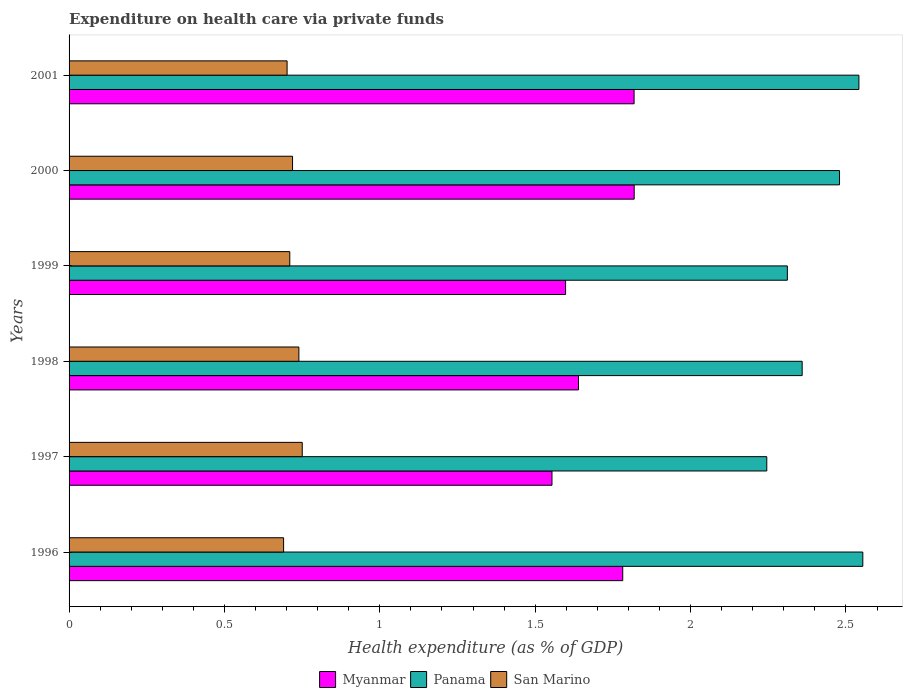How many different coloured bars are there?
Provide a succinct answer. 3. Are the number of bars per tick equal to the number of legend labels?
Offer a terse response. Yes. Are the number of bars on each tick of the Y-axis equal?
Keep it short and to the point. Yes. How many bars are there on the 6th tick from the top?
Your response must be concise. 3. How many bars are there on the 1st tick from the bottom?
Keep it short and to the point. 3. In how many cases, is the number of bars for a given year not equal to the number of legend labels?
Give a very brief answer. 0. What is the expenditure made on health care in Panama in 1996?
Give a very brief answer. 2.55. Across all years, what is the maximum expenditure made on health care in San Marino?
Your answer should be compact. 0.75. Across all years, what is the minimum expenditure made on health care in Myanmar?
Give a very brief answer. 1.55. What is the total expenditure made on health care in San Marino in the graph?
Offer a terse response. 4.31. What is the difference between the expenditure made on health care in Myanmar in 1997 and that in 2000?
Provide a short and direct response. -0.26. What is the difference between the expenditure made on health care in Panama in 2000 and the expenditure made on health care in Myanmar in 1998?
Offer a very short reply. 0.84. What is the average expenditure made on health care in San Marino per year?
Ensure brevity in your answer.  0.72. In the year 1996, what is the difference between the expenditure made on health care in Myanmar and expenditure made on health care in Panama?
Ensure brevity in your answer.  -0.77. What is the ratio of the expenditure made on health care in Myanmar in 1997 to that in 2001?
Your answer should be compact. 0.85. Is the difference between the expenditure made on health care in Myanmar in 1996 and 1999 greater than the difference between the expenditure made on health care in Panama in 1996 and 1999?
Your answer should be very brief. No. What is the difference between the highest and the second highest expenditure made on health care in Myanmar?
Provide a succinct answer. 0. What is the difference between the highest and the lowest expenditure made on health care in San Marino?
Your answer should be compact. 0.06. In how many years, is the expenditure made on health care in Myanmar greater than the average expenditure made on health care in Myanmar taken over all years?
Provide a short and direct response. 3. Is the sum of the expenditure made on health care in Panama in 1997 and 1998 greater than the maximum expenditure made on health care in San Marino across all years?
Provide a short and direct response. Yes. What does the 2nd bar from the top in 1999 represents?
Give a very brief answer. Panama. What does the 2nd bar from the bottom in 1999 represents?
Offer a very short reply. Panama. How many years are there in the graph?
Give a very brief answer. 6. Are the values on the major ticks of X-axis written in scientific E-notation?
Your answer should be compact. No. Where does the legend appear in the graph?
Provide a short and direct response. Bottom center. How many legend labels are there?
Your answer should be compact. 3. How are the legend labels stacked?
Your response must be concise. Horizontal. What is the title of the graph?
Your answer should be compact. Expenditure on health care via private funds. What is the label or title of the X-axis?
Offer a terse response. Health expenditure (as % of GDP). What is the Health expenditure (as % of GDP) of Myanmar in 1996?
Provide a short and direct response. 1.78. What is the Health expenditure (as % of GDP) in Panama in 1996?
Your answer should be very brief. 2.55. What is the Health expenditure (as % of GDP) of San Marino in 1996?
Offer a very short reply. 0.69. What is the Health expenditure (as % of GDP) of Myanmar in 1997?
Provide a succinct answer. 1.55. What is the Health expenditure (as % of GDP) in Panama in 1997?
Ensure brevity in your answer.  2.25. What is the Health expenditure (as % of GDP) of San Marino in 1997?
Your answer should be very brief. 0.75. What is the Health expenditure (as % of GDP) in Myanmar in 1998?
Your response must be concise. 1.64. What is the Health expenditure (as % of GDP) in Panama in 1998?
Give a very brief answer. 2.36. What is the Health expenditure (as % of GDP) in San Marino in 1998?
Ensure brevity in your answer.  0.74. What is the Health expenditure (as % of GDP) in Myanmar in 1999?
Your answer should be compact. 1.6. What is the Health expenditure (as % of GDP) of Panama in 1999?
Provide a succinct answer. 2.31. What is the Health expenditure (as % of GDP) in San Marino in 1999?
Your answer should be very brief. 0.71. What is the Health expenditure (as % of GDP) of Myanmar in 2000?
Make the answer very short. 1.82. What is the Health expenditure (as % of GDP) in Panama in 2000?
Ensure brevity in your answer.  2.48. What is the Health expenditure (as % of GDP) in San Marino in 2000?
Offer a terse response. 0.72. What is the Health expenditure (as % of GDP) in Myanmar in 2001?
Ensure brevity in your answer.  1.82. What is the Health expenditure (as % of GDP) in Panama in 2001?
Offer a terse response. 2.54. What is the Health expenditure (as % of GDP) of San Marino in 2001?
Provide a short and direct response. 0.7. Across all years, what is the maximum Health expenditure (as % of GDP) of Myanmar?
Your answer should be compact. 1.82. Across all years, what is the maximum Health expenditure (as % of GDP) of Panama?
Your answer should be compact. 2.55. Across all years, what is the maximum Health expenditure (as % of GDP) of San Marino?
Your answer should be very brief. 0.75. Across all years, what is the minimum Health expenditure (as % of GDP) of Myanmar?
Ensure brevity in your answer.  1.55. Across all years, what is the minimum Health expenditure (as % of GDP) in Panama?
Offer a very short reply. 2.25. Across all years, what is the minimum Health expenditure (as % of GDP) in San Marino?
Keep it short and to the point. 0.69. What is the total Health expenditure (as % of GDP) of Myanmar in the graph?
Provide a succinct answer. 10.21. What is the total Health expenditure (as % of GDP) of Panama in the graph?
Offer a very short reply. 14.49. What is the total Health expenditure (as % of GDP) in San Marino in the graph?
Give a very brief answer. 4.31. What is the difference between the Health expenditure (as % of GDP) in Myanmar in 1996 and that in 1997?
Your response must be concise. 0.23. What is the difference between the Health expenditure (as % of GDP) of Panama in 1996 and that in 1997?
Your answer should be compact. 0.31. What is the difference between the Health expenditure (as % of GDP) of San Marino in 1996 and that in 1997?
Provide a succinct answer. -0.06. What is the difference between the Health expenditure (as % of GDP) of Myanmar in 1996 and that in 1998?
Ensure brevity in your answer.  0.14. What is the difference between the Health expenditure (as % of GDP) in Panama in 1996 and that in 1998?
Your answer should be very brief. 0.2. What is the difference between the Health expenditure (as % of GDP) in San Marino in 1996 and that in 1998?
Make the answer very short. -0.05. What is the difference between the Health expenditure (as % of GDP) in Myanmar in 1996 and that in 1999?
Your response must be concise. 0.18. What is the difference between the Health expenditure (as % of GDP) of Panama in 1996 and that in 1999?
Your response must be concise. 0.24. What is the difference between the Health expenditure (as % of GDP) of San Marino in 1996 and that in 1999?
Your answer should be compact. -0.02. What is the difference between the Health expenditure (as % of GDP) in Myanmar in 1996 and that in 2000?
Keep it short and to the point. -0.04. What is the difference between the Health expenditure (as % of GDP) of Panama in 1996 and that in 2000?
Make the answer very short. 0.07. What is the difference between the Health expenditure (as % of GDP) in San Marino in 1996 and that in 2000?
Your answer should be compact. -0.03. What is the difference between the Health expenditure (as % of GDP) of Myanmar in 1996 and that in 2001?
Your response must be concise. -0.04. What is the difference between the Health expenditure (as % of GDP) in Panama in 1996 and that in 2001?
Your answer should be compact. 0.01. What is the difference between the Health expenditure (as % of GDP) of San Marino in 1996 and that in 2001?
Your answer should be very brief. -0.01. What is the difference between the Health expenditure (as % of GDP) of Myanmar in 1997 and that in 1998?
Provide a short and direct response. -0.09. What is the difference between the Health expenditure (as % of GDP) in Panama in 1997 and that in 1998?
Keep it short and to the point. -0.11. What is the difference between the Health expenditure (as % of GDP) in San Marino in 1997 and that in 1998?
Offer a very short reply. 0.01. What is the difference between the Health expenditure (as % of GDP) in Myanmar in 1997 and that in 1999?
Offer a terse response. -0.04. What is the difference between the Health expenditure (as % of GDP) of Panama in 1997 and that in 1999?
Keep it short and to the point. -0.07. What is the difference between the Health expenditure (as % of GDP) of San Marino in 1997 and that in 1999?
Make the answer very short. 0.04. What is the difference between the Health expenditure (as % of GDP) in Myanmar in 1997 and that in 2000?
Keep it short and to the point. -0.26. What is the difference between the Health expenditure (as % of GDP) of Panama in 1997 and that in 2000?
Your response must be concise. -0.23. What is the difference between the Health expenditure (as % of GDP) in San Marino in 1997 and that in 2000?
Ensure brevity in your answer.  0.03. What is the difference between the Health expenditure (as % of GDP) of Myanmar in 1997 and that in 2001?
Provide a short and direct response. -0.26. What is the difference between the Health expenditure (as % of GDP) in Panama in 1997 and that in 2001?
Offer a terse response. -0.3. What is the difference between the Health expenditure (as % of GDP) of San Marino in 1997 and that in 2001?
Keep it short and to the point. 0.05. What is the difference between the Health expenditure (as % of GDP) of Myanmar in 1998 and that in 1999?
Provide a succinct answer. 0.04. What is the difference between the Health expenditure (as % of GDP) of Panama in 1998 and that in 1999?
Give a very brief answer. 0.05. What is the difference between the Health expenditure (as % of GDP) of San Marino in 1998 and that in 1999?
Your answer should be very brief. 0.03. What is the difference between the Health expenditure (as % of GDP) in Myanmar in 1998 and that in 2000?
Your response must be concise. -0.18. What is the difference between the Health expenditure (as % of GDP) of Panama in 1998 and that in 2000?
Keep it short and to the point. -0.12. What is the difference between the Health expenditure (as % of GDP) of San Marino in 1998 and that in 2000?
Your answer should be very brief. 0.02. What is the difference between the Health expenditure (as % of GDP) in Myanmar in 1998 and that in 2001?
Offer a very short reply. -0.18. What is the difference between the Health expenditure (as % of GDP) in Panama in 1998 and that in 2001?
Your answer should be very brief. -0.18. What is the difference between the Health expenditure (as % of GDP) in San Marino in 1998 and that in 2001?
Make the answer very short. 0.04. What is the difference between the Health expenditure (as % of GDP) in Myanmar in 1999 and that in 2000?
Provide a short and direct response. -0.22. What is the difference between the Health expenditure (as % of GDP) in Panama in 1999 and that in 2000?
Provide a short and direct response. -0.17. What is the difference between the Health expenditure (as % of GDP) of San Marino in 1999 and that in 2000?
Offer a terse response. -0.01. What is the difference between the Health expenditure (as % of GDP) of Myanmar in 1999 and that in 2001?
Provide a succinct answer. -0.22. What is the difference between the Health expenditure (as % of GDP) in Panama in 1999 and that in 2001?
Your response must be concise. -0.23. What is the difference between the Health expenditure (as % of GDP) of San Marino in 1999 and that in 2001?
Your response must be concise. 0.01. What is the difference between the Health expenditure (as % of GDP) of Myanmar in 2000 and that in 2001?
Provide a succinct answer. 0. What is the difference between the Health expenditure (as % of GDP) of Panama in 2000 and that in 2001?
Offer a very short reply. -0.06. What is the difference between the Health expenditure (as % of GDP) in San Marino in 2000 and that in 2001?
Your response must be concise. 0.02. What is the difference between the Health expenditure (as % of GDP) of Myanmar in 1996 and the Health expenditure (as % of GDP) of Panama in 1997?
Your answer should be very brief. -0.46. What is the difference between the Health expenditure (as % of GDP) of Myanmar in 1996 and the Health expenditure (as % of GDP) of San Marino in 1997?
Offer a terse response. 1.03. What is the difference between the Health expenditure (as % of GDP) in Panama in 1996 and the Health expenditure (as % of GDP) in San Marino in 1997?
Make the answer very short. 1.8. What is the difference between the Health expenditure (as % of GDP) in Myanmar in 1996 and the Health expenditure (as % of GDP) in Panama in 1998?
Offer a terse response. -0.58. What is the difference between the Health expenditure (as % of GDP) in Myanmar in 1996 and the Health expenditure (as % of GDP) in San Marino in 1998?
Give a very brief answer. 1.04. What is the difference between the Health expenditure (as % of GDP) of Panama in 1996 and the Health expenditure (as % of GDP) of San Marino in 1998?
Keep it short and to the point. 1.81. What is the difference between the Health expenditure (as % of GDP) of Myanmar in 1996 and the Health expenditure (as % of GDP) of Panama in 1999?
Give a very brief answer. -0.53. What is the difference between the Health expenditure (as % of GDP) of Myanmar in 1996 and the Health expenditure (as % of GDP) of San Marino in 1999?
Keep it short and to the point. 1.07. What is the difference between the Health expenditure (as % of GDP) in Panama in 1996 and the Health expenditure (as % of GDP) in San Marino in 1999?
Offer a very short reply. 1.84. What is the difference between the Health expenditure (as % of GDP) in Myanmar in 1996 and the Health expenditure (as % of GDP) in Panama in 2000?
Keep it short and to the point. -0.7. What is the difference between the Health expenditure (as % of GDP) of Panama in 1996 and the Health expenditure (as % of GDP) of San Marino in 2000?
Offer a terse response. 1.83. What is the difference between the Health expenditure (as % of GDP) in Myanmar in 1996 and the Health expenditure (as % of GDP) in Panama in 2001?
Make the answer very short. -0.76. What is the difference between the Health expenditure (as % of GDP) in Panama in 1996 and the Health expenditure (as % of GDP) in San Marino in 2001?
Ensure brevity in your answer.  1.85. What is the difference between the Health expenditure (as % of GDP) in Myanmar in 1997 and the Health expenditure (as % of GDP) in Panama in 1998?
Offer a terse response. -0.81. What is the difference between the Health expenditure (as % of GDP) in Myanmar in 1997 and the Health expenditure (as % of GDP) in San Marino in 1998?
Provide a short and direct response. 0.81. What is the difference between the Health expenditure (as % of GDP) of Panama in 1997 and the Health expenditure (as % of GDP) of San Marino in 1998?
Provide a succinct answer. 1.51. What is the difference between the Health expenditure (as % of GDP) of Myanmar in 1997 and the Health expenditure (as % of GDP) of Panama in 1999?
Provide a succinct answer. -0.76. What is the difference between the Health expenditure (as % of GDP) in Myanmar in 1997 and the Health expenditure (as % of GDP) in San Marino in 1999?
Ensure brevity in your answer.  0.84. What is the difference between the Health expenditure (as % of GDP) in Panama in 1997 and the Health expenditure (as % of GDP) in San Marino in 1999?
Offer a very short reply. 1.53. What is the difference between the Health expenditure (as % of GDP) in Myanmar in 1997 and the Health expenditure (as % of GDP) in Panama in 2000?
Offer a terse response. -0.93. What is the difference between the Health expenditure (as % of GDP) of Myanmar in 1997 and the Health expenditure (as % of GDP) of San Marino in 2000?
Ensure brevity in your answer.  0.83. What is the difference between the Health expenditure (as % of GDP) in Panama in 1997 and the Health expenditure (as % of GDP) in San Marino in 2000?
Provide a succinct answer. 1.53. What is the difference between the Health expenditure (as % of GDP) of Myanmar in 1997 and the Health expenditure (as % of GDP) of Panama in 2001?
Your response must be concise. -0.99. What is the difference between the Health expenditure (as % of GDP) of Myanmar in 1997 and the Health expenditure (as % of GDP) of San Marino in 2001?
Offer a terse response. 0.85. What is the difference between the Health expenditure (as % of GDP) in Panama in 1997 and the Health expenditure (as % of GDP) in San Marino in 2001?
Ensure brevity in your answer.  1.54. What is the difference between the Health expenditure (as % of GDP) in Myanmar in 1998 and the Health expenditure (as % of GDP) in Panama in 1999?
Your answer should be compact. -0.67. What is the difference between the Health expenditure (as % of GDP) in Myanmar in 1998 and the Health expenditure (as % of GDP) in San Marino in 1999?
Your answer should be compact. 0.93. What is the difference between the Health expenditure (as % of GDP) in Panama in 1998 and the Health expenditure (as % of GDP) in San Marino in 1999?
Offer a very short reply. 1.65. What is the difference between the Health expenditure (as % of GDP) in Myanmar in 1998 and the Health expenditure (as % of GDP) in Panama in 2000?
Make the answer very short. -0.84. What is the difference between the Health expenditure (as % of GDP) in Myanmar in 1998 and the Health expenditure (as % of GDP) in San Marino in 2000?
Provide a succinct answer. 0.92. What is the difference between the Health expenditure (as % of GDP) in Panama in 1998 and the Health expenditure (as % of GDP) in San Marino in 2000?
Provide a short and direct response. 1.64. What is the difference between the Health expenditure (as % of GDP) of Myanmar in 1998 and the Health expenditure (as % of GDP) of Panama in 2001?
Keep it short and to the point. -0.9. What is the difference between the Health expenditure (as % of GDP) in Myanmar in 1998 and the Health expenditure (as % of GDP) in San Marino in 2001?
Provide a short and direct response. 0.94. What is the difference between the Health expenditure (as % of GDP) of Panama in 1998 and the Health expenditure (as % of GDP) of San Marino in 2001?
Provide a short and direct response. 1.66. What is the difference between the Health expenditure (as % of GDP) in Myanmar in 1999 and the Health expenditure (as % of GDP) in Panama in 2000?
Offer a very short reply. -0.88. What is the difference between the Health expenditure (as % of GDP) of Myanmar in 1999 and the Health expenditure (as % of GDP) of San Marino in 2000?
Your answer should be compact. 0.88. What is the difference between the Health expenditure (as % of GDP) in Panama in 1999 and the Health expenditure (as % of GDP) in San Marino in 2000?
Keep it short and to the point. 1.59. What is the difference between the Health expenditure (as % of GDP) of Myanmar in 1999 and the Health expenditure (as % of GDP) of Panama in 2001?
Ensure brevity in your answer.  -0.94. What is the difference between the Health expenditure (as % of GDP) in Myanmar in 1999 and the Health expenditure (as % of GDP) in San Marino in 2001?
Give a very brief answer. 0.9. What is the difference between the Health expenditure (as % of GDP) of Panama in 1999 and the Health expenditure (as % of GDP) of San Marino in 2001?
Keep it short and to the point. 1.61. What is the difference between the Health expenditure (as % of GDP) in Myanmar in 2000 and the Health expenditure (as % of GDP) in Panama in 2001?
Your answer should be very brief. -0.72. What is the difference between the Health expenditure (as % of GDP) of Myanmar in 2000 and the Health expenditure (as % of GDP) of San Marino in 2001?
Keep it short and to the point. 1.12. What is the difference between the Health expenditure (as % of GDP) of Panama in 2000 and the Health expenditure (as % of GDP) of San Marino in 2001?
Offer a terse response. 1.78. What is the average Health expenditure (as % of GDP) in Myanmar per year?
Provide a succinct answer. 1.7. What is the average Health expenditure (as % of GDP) of Panama per year?
Your answer should be compact. 2.42. What is the average Health expenditure (as % of GDP) in San Marino per year?
Ensure brevity in your answer.  0.72. In the year 1996, what is the difference between the Health expenditure (as % of GDP) in Myanmar and Health expenditure (as % of GDP) in Panama?
Ensure brevity in your answer.  -0.77. In the year 1996, what is the difference between the Health expenditure (as % of GDP) of Myanmar and Health expenditure (as % of GDP) of San Marino?
Keep it short and to the point. 1.09. In the year 1996, what is the difference between the Health expenditure (as % of GDP) of Panama and Health expenditure (as % of GDP) of San Marino?
Provide a short and direct response. 1.86. In the year 1997, what is the difference between the Health expenditure (as % of GDP) in Myanmar and Health expenditure (as % of GDP) in Panama?
Ensure brevity in your answer.  -0.69. In the year 1997, what is the difference between the Health expenditure (as % of GDP) of Myanmar and Health expenditure (as % of GDP) of San Marino?
Offer a very short reply. 0.8. In the year 1997, what is the difference between the Health expenditure (as % of GDP) in Panama and Health expenditure (as % of GDP) in San Marino?
Offer a terse response. 1.49. In the year 1998, what is the difference between the Health expenditure (as % of GDP) in Myanmar and Health expenditure (as % of GDP) in Panama?
Offer a terse response. -0.72. In the year 1998, what is the difference between the Health expenditure (as % of GDP) of Myanmar and Health expenditure (as % of GDP) of San Marino?
Your response must be concise. 0.9. In the year 1998, what is the difference between the Health expenditure (as % of GDP) in Panama and Health expenditure (as % of GDP) in San Marino?
Your answer should be compact. 1.62. In the year 1999, what is the difference between the Health expenditure (as % of GDP) of Myanmar and Health expenditure (as % of GDP) of Panama?
Your answer should be compact. -0.71. In the year 1999, what is the difference between the Health expenditure (as % of GDP) in Myanmar and Health expenditure (as % of GDP) in San Marino?
Provide a short and direct response. 0.89. In the year 1999, what is the difference between the Health expenditure (as % of GDP) in Panama and Health expenditure (as % of GDP) in San Marino?
Offer a terse response. 1.6. In the year 2000, what is the difference between the Health expenditure (as % of GDP) of Myanmar and Health expenditure (as % of GDP) of Panama?
Offer a terse response. -0.66. In the year 2000, what is the difference between the Health expenditure (as % of GDP) in Myanmar and Health expenditure (as % of GDP) in San Marino?
Keep it short and to the point. 1.1. In the year 2000, what is the difference between the Health expenditure (as % of GDP) of Panama and Health expenditure (as % of GDP) of San Marino?
Your answer should be very brief. 1.76. In the year 2001, what is the difference between the Health expenditure (as % of GDP) in Myanmar and Health expenditure (as % of GDP) in Panama?
Give a very brief answer. -0.72. In the year 2001, what is the difference between the Health expenditure (as % of GDP) of Myanmar and Health expenditure (as % of GDP) of San Marino?
Your answer should be compact. 1.12. In the year 2001, what is the difference between the Health expenditure (as % of GDP) of Panama and Health expenditure (as % of GDP) of San Marino?
Your answer should be very brief. 1.84. What is the ratio of the Health expenditure (as % of GDP) in Myanmar in 1996 to that in 1997?
Provide a succinct answer. 1.15. What is the ratio of the Health expenditure (as % of GDP) of Panama in 1996 to that in 1997?
Offer a terse response. 1.14. What is the ratio of the Health expenditure (as % of GDP) in San Marino in 1996 to that in 1997?
Provide a succinct answer. 0.92. What is the ratio of the Health expenditure (as % of GDP) of Myanmar in 1996 to that in 1998?
Keep it short and to the point. 1.09. What is the ratio of the Health expenditure (as % of GDP) in Panama in 1996 to that in 1998?
Make the answer very short. 1.08. What is the ratio of the Health expenditure (as % of GDP) in San Marino in 1996 to that in 1998?
Keep it short and to the point. 0.93. What is the ratio of the Health expenditure (as % of GDP) in Myanmar in 1996 to that in 1999?
Make the answer very short. 1.12. What is the ratio of the Health expenditure (as % of GDP) in Panama in 1996 to that in 1999?
Offer a very short reply. 1.1. What is the ratio of the Health expenditure (as % of GDP) in San Marino in 1996 to that in 1999?
Your response must be concise. 0.97. What is the ratio of the Health expenditure (as % of GDP) of Myanmar in 1996 to that in 2000?
Your answer should be very brief. 0.98. What is the ratio of the Health expenditure (as % of GDP) in Panama in 1996 to that in 2000?
Offer a terse response. 1.03. What is the ratio of the Health expenditure (as % of GDP) in San Marino in 1996 to that in 2000?
Make the answer very short. 0.96. What is the ratio of the Health expenditure (as % of GDP) of Myanmar in 1996 to that in 2001?
Provide a succinct answer. 0.98. What is the ratio of the Health expenditure (as % of GDP) in Panama in 1996 to that in 2001?
Provide a succinct answer. 1. What is the ratio of the Health expenditure (as % of GDP) in San Marino in 1996 to that in 2001?
Offer a terse response. 0.98. What is the ratio of the Health expenditure (as % of GDP) in Myanmar in 1997 to that in 1998?
Keep it short and to the point. 0.95. What is the ratio of the Health expenditure (as % of GDP) in Panama in 1997 to that in 1998?
Give a very brief answer. 0.95. What is the ratio of the Health expenditure (as % of GDP) in San Marino in 1997 to that in 1998?
Give a very brief answer. 1.01. What is the ratio of the Health expenditure (as % of GDP) in Myanmar in 1997 to that in 1999?
Provide a short and direct response. 0.97. What is the ratio of the Health expenditure (as % of GDP) in Panama in 1997 to that in 1999?
Give a very brief answer. 0.97. What is the ratio of the Health expenditure (as % of GDP) in San Marino in 1997 to that in 1999?
Give a very brief answer. 1.06. What is the ratio of the Health expenditure (as % of GDP) of Myanmar in 1997 to that in 2000?
Your answer should be very brief. 0.85. What is the ratio of the Health expenditure (as % of GDP) in Panama in 1997 to that in 2000?
Offer a terse response. 0.91. What is the ratio of the Health expenditure (as % of GDP) of San Marino in 1997 to that in 2000?
Provide a short and direct response. 1.04. What is the ratio of the Health expenditure (as % of GDP) in Myanmar in 1997 to that in 2001?
Offer a very short reply. 0.85. What is the ratio of the Health expenditure (as % of GDP) of Panama in 1997 to that in 2001?
Your response must be concise. 0.88. What is the ratio of the Health expenditure (as % of GDP) of San Marino in 1997 to that in 2001?
Keep it short and to the point. 1.07. What is the ratio of the Health expenditure (as % of GDP) in Myanmar in 1998 to that in 1999?
Ensure brevity in your answer.  1.03. What is the ratio of the Health expenditure (as % of GDP) of Panama in 1998 to that in 1999?
Provide a succinct answer. 1.02. What is the ratio of the Health expenditure (as % of GDP) in San Marino in 1998 to that in 1999?
Make the answer very short. 1.04. What is the ratio of the Health expenditure (as % of GDP) in Myanmar in 1998 to that in 2000?
Make the answer very short. 0.9. What is the ratio of the Health expenditure (as % of GDP) of Panama in 1998 to that in 2000?
Ensure brevity in your answer.  0.95. What is the ratio of the Health expenditure (as % of GDP) of San Marino in 1998 to that in 2000?
Make the answer very short. 1.03. What is the ratio of the Health expenditure (as % of GDP) in Myanmar in 1998 to that in 2001?
Ensure brevity in your answer.  0.9. What is the ratio of the Health expenditure (as % of GDP) in Panama in 1998 to that in 2001?
Make the answer very short. 0.93. What is the ratio of the Health expenditure (as % of GDP) in San Marino in 1998 to that in 2001?
Keep it short and to the point. 1.05. What is the ratio of the Health expenditure (as % of GDP) in Myanmar in 1999 to that in 2000?
Your answer should be compact. 0.88. What is the ratio of the Health expenditure (as % of GDP) in Panama in 1999 to that in 2000?
Offer a very short reply. 0.93. What is the ratio of the Health expenditure (as % of GDP) of San Marino in 1999 to that in 2000?
Make the answer very short. 0.99. What is the ratio of the Health expenditure (as % of GDP) in Myanmar in 1999 to that in 2001?
Offer a very short reply. 0.88. What is the ratio of the Health expenditure (as % of GDP) in Panama in 1999 to that in 2001?
Make the answer very short. 0.91. What is the ratio of the Health expenditure (as % of GDP) in San Marino in 1999 to that in 2001?
Ensure brevity in your answer.  1.01. What is the ratio of the Health expenditure (as % of GDP) of Myanmar in 2000 to that in 2001?
Offer a terse response. 1. What is the ratio of the Health expenditure (as % of GDP) of Panama in 2000 to that in 2001?
Provide a short and direct response. 0.98. What is the difference between the highest and the second highest Health expenditure (as % of GDP) in Panama?
Provide a succinct answer. 0.01. What is the difference between the highest and the second highest Health expenditure (as % of GDP) in San Marino?
Your response must be concise. 0.01. What is the difference between the highest and the lowest Health expenditure (as % of GDP) in Myanmar?
Ensure brevity in your answer.  0.26. What is the difference between the highest and the lowest Health expenditure (as % of GDP) in Panama?
Offer a terse response. 0.31. What is the difference between the highest and the lowest Health expenditure (as % of GDP) in San Marino?
Your response must be concise. 0.06. 